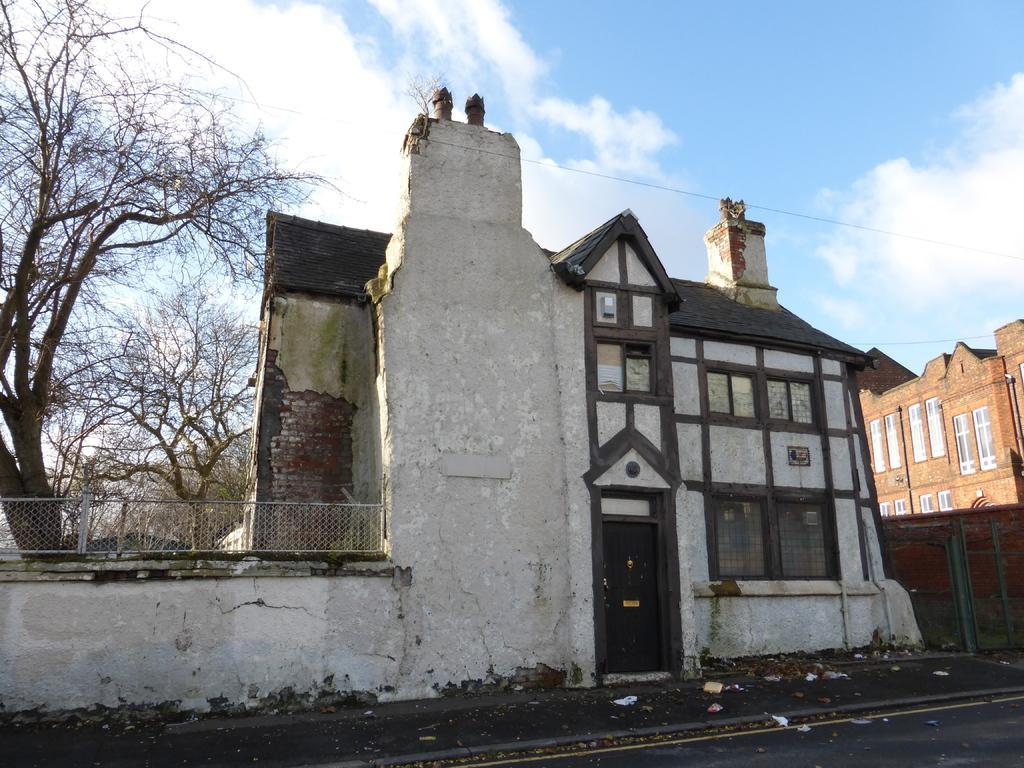In one or two sentences, can you explain what this image depicts? In the picture we can see the road, stone wall, door, dry trees, houses, wire and the blue color sky with clouds in the background. 